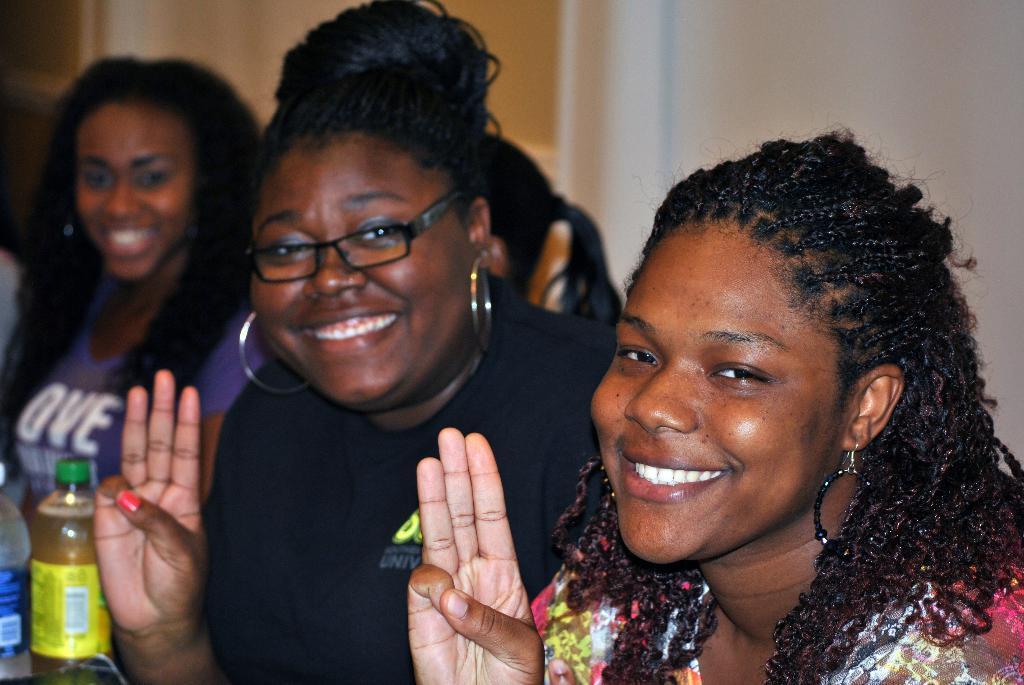How would you summarize this image in a sentence or two? This image consists of three women. On the left, we can see two bottles. In the background, there is a wall. 